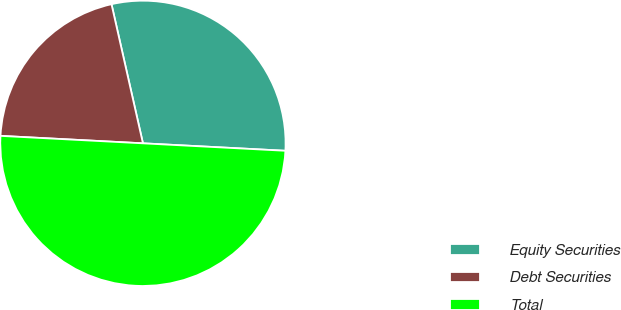<chart> <loc_0><loc_0><loc_500><loc_500><pie_chart><fcel>Equity Securities<fcel>Debt Securities<fcel>Total<nl><fcel>29.37%<fcel>20.63%<fcel>50.0%<nl></chart> 